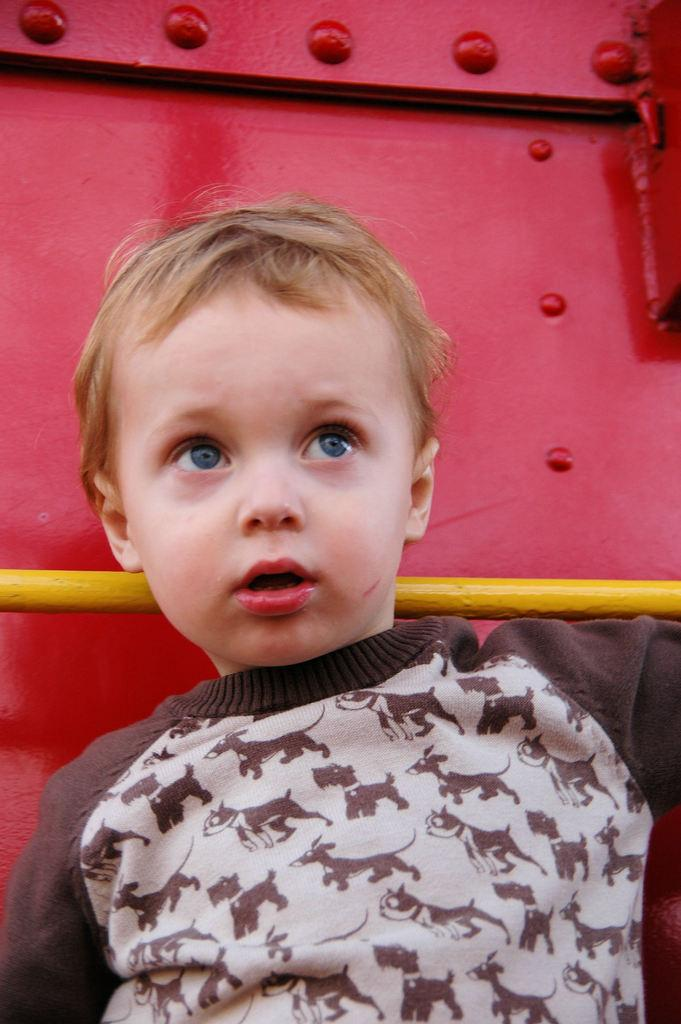Who is the main subject in the image? There is a small boy in the image. What is the boy doing in the image? The boy is standing. What can be seen in the background of the image? There is a red colored metal in the backdrop of the image. What type of leaf is falling from the red colored metal in the image? There is no leaf present in the image, and the red colored metal is not associated with any falling leaves. 